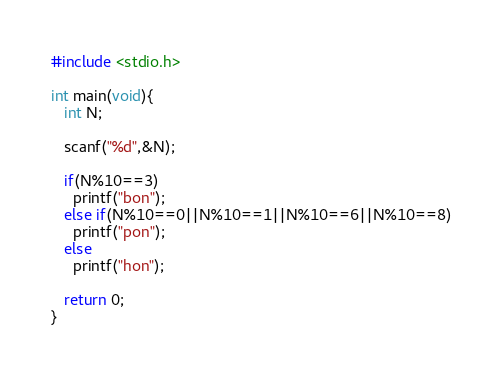Convert code to text. <code><loc_0><loc_0><loc_500><loc_500><_C_>#include <stdio.h>
 
int main(void){
   int N;

   scanf("%d",&N);

   if(N%10==3)
     printf("bon");
   else if(N%10==0||N%10==1||N%10==6||N%10==8)
     printf("pon");
   else
     printf("hon");
     
   return 0;
}</code> 